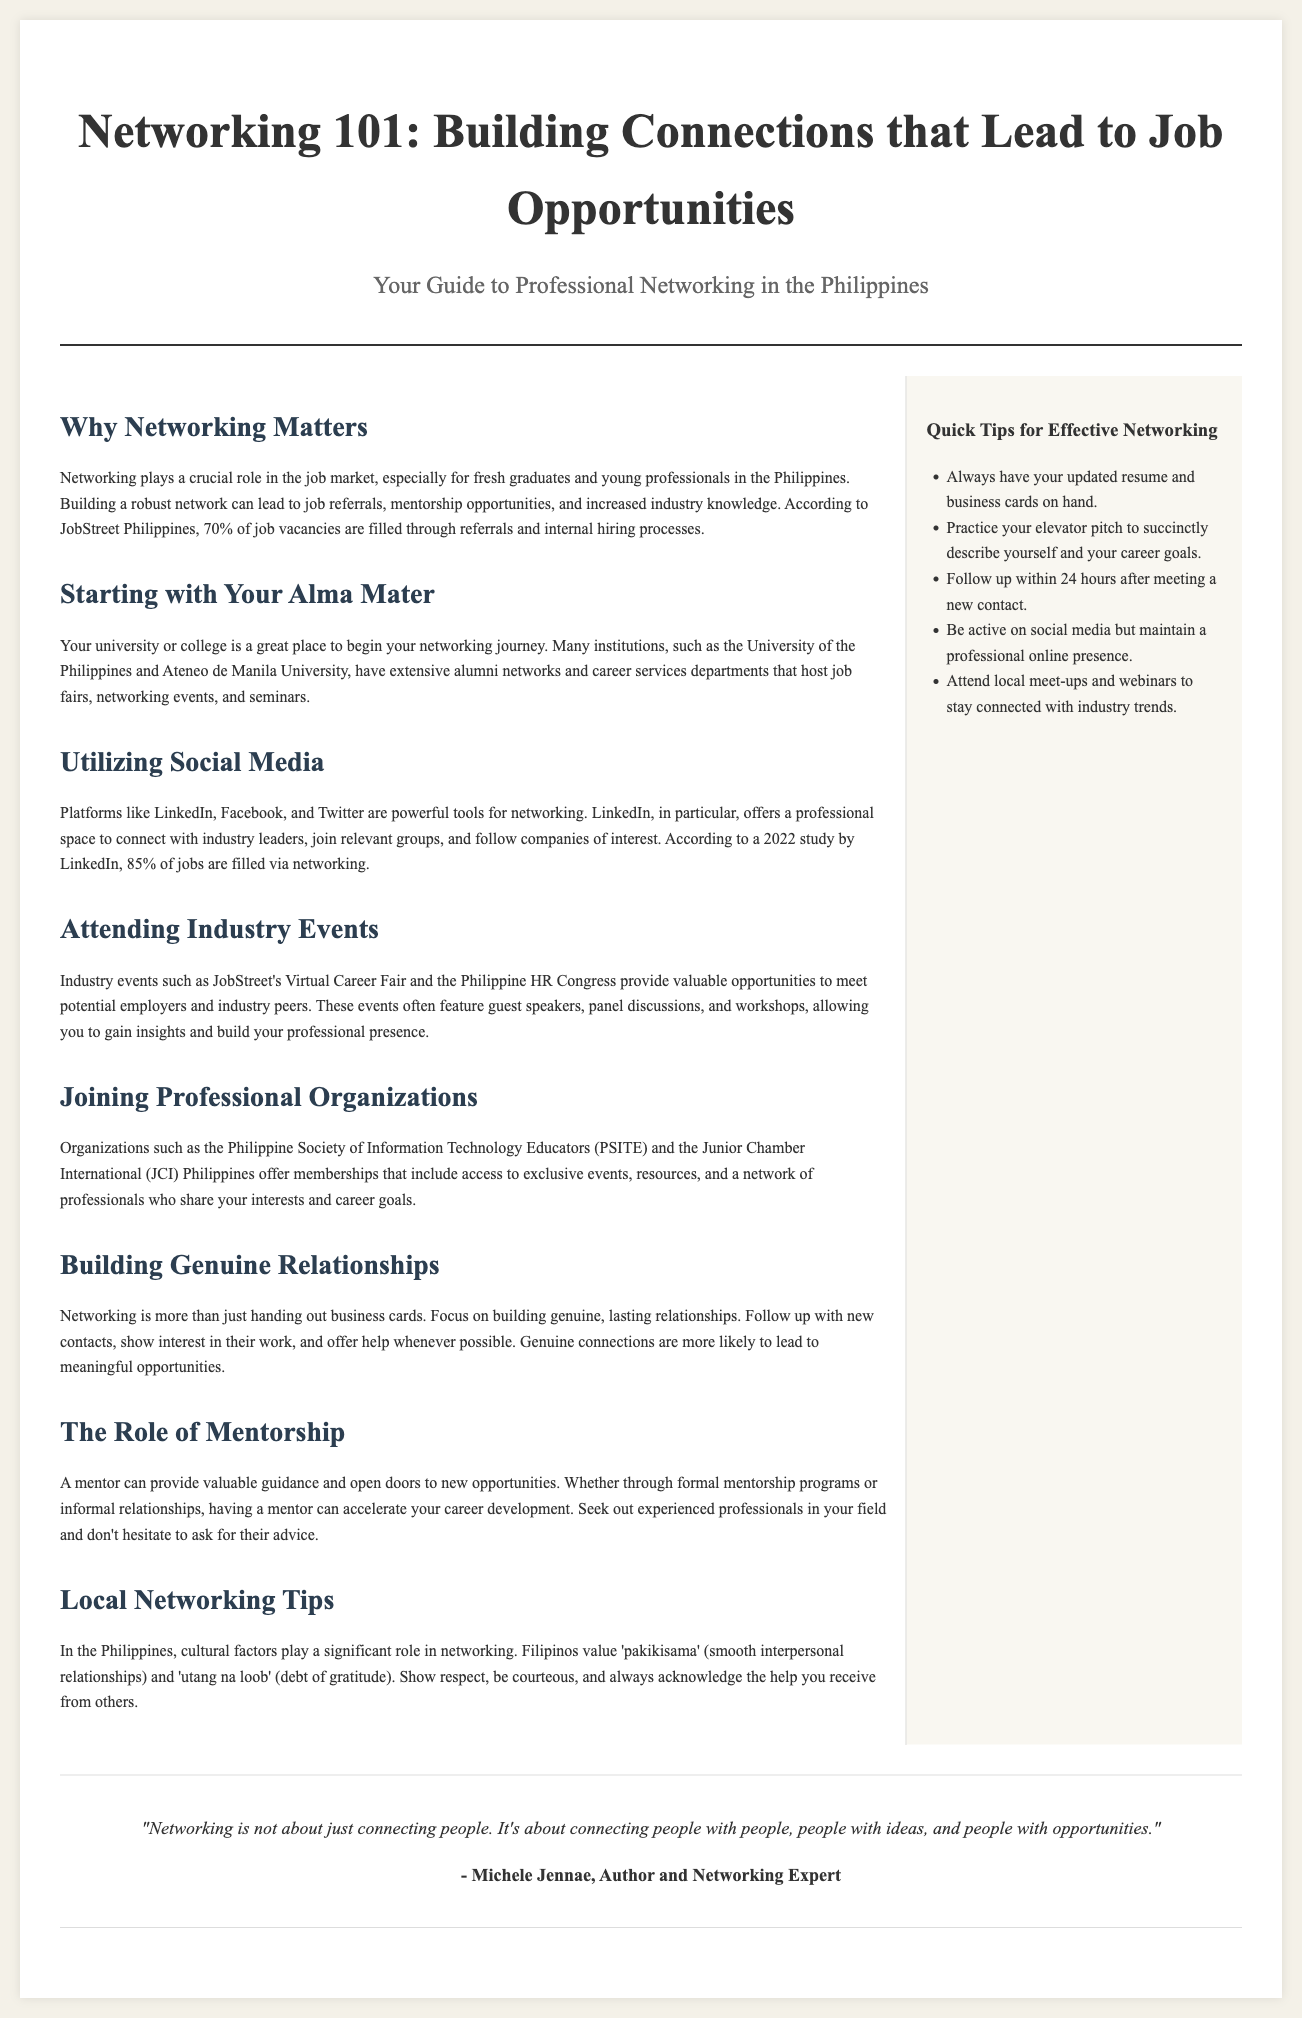What percentage of job vacancies are filled through referrals? The document states that, according to JobStreet Philippines, 70% of job vacancies are filled through referrals and internal hiring processes.
Answer: 70% Which university is mentioned as having an extensive alumni network? The document mentions the University of the Philippines as having an extensive alumni network and career services departments that host job fairs, networking events, and seminars.
Answer: University of the Philippines What is a crucial tool for networking mentioned in the document? The document highlights LinkedIn as a powerful platform for professional networking and connecting with industry leaders.
Answer: LinkedIn What is one of the cultural factors that influence networking in the Philippines? The document discusses cultural factors such as 'pakikisama' (smooth interpersonal relationships) and 'utang na loob' (debt of gratitude) that play a significant role in networking.
Answer: Pakikisama What does the quote by Michele Jennae emphasize? The quote emphasizes the importance of connecting people with ideas and opportunities, not just with one another.
Answer: Connecting people with ideas and opportunities 